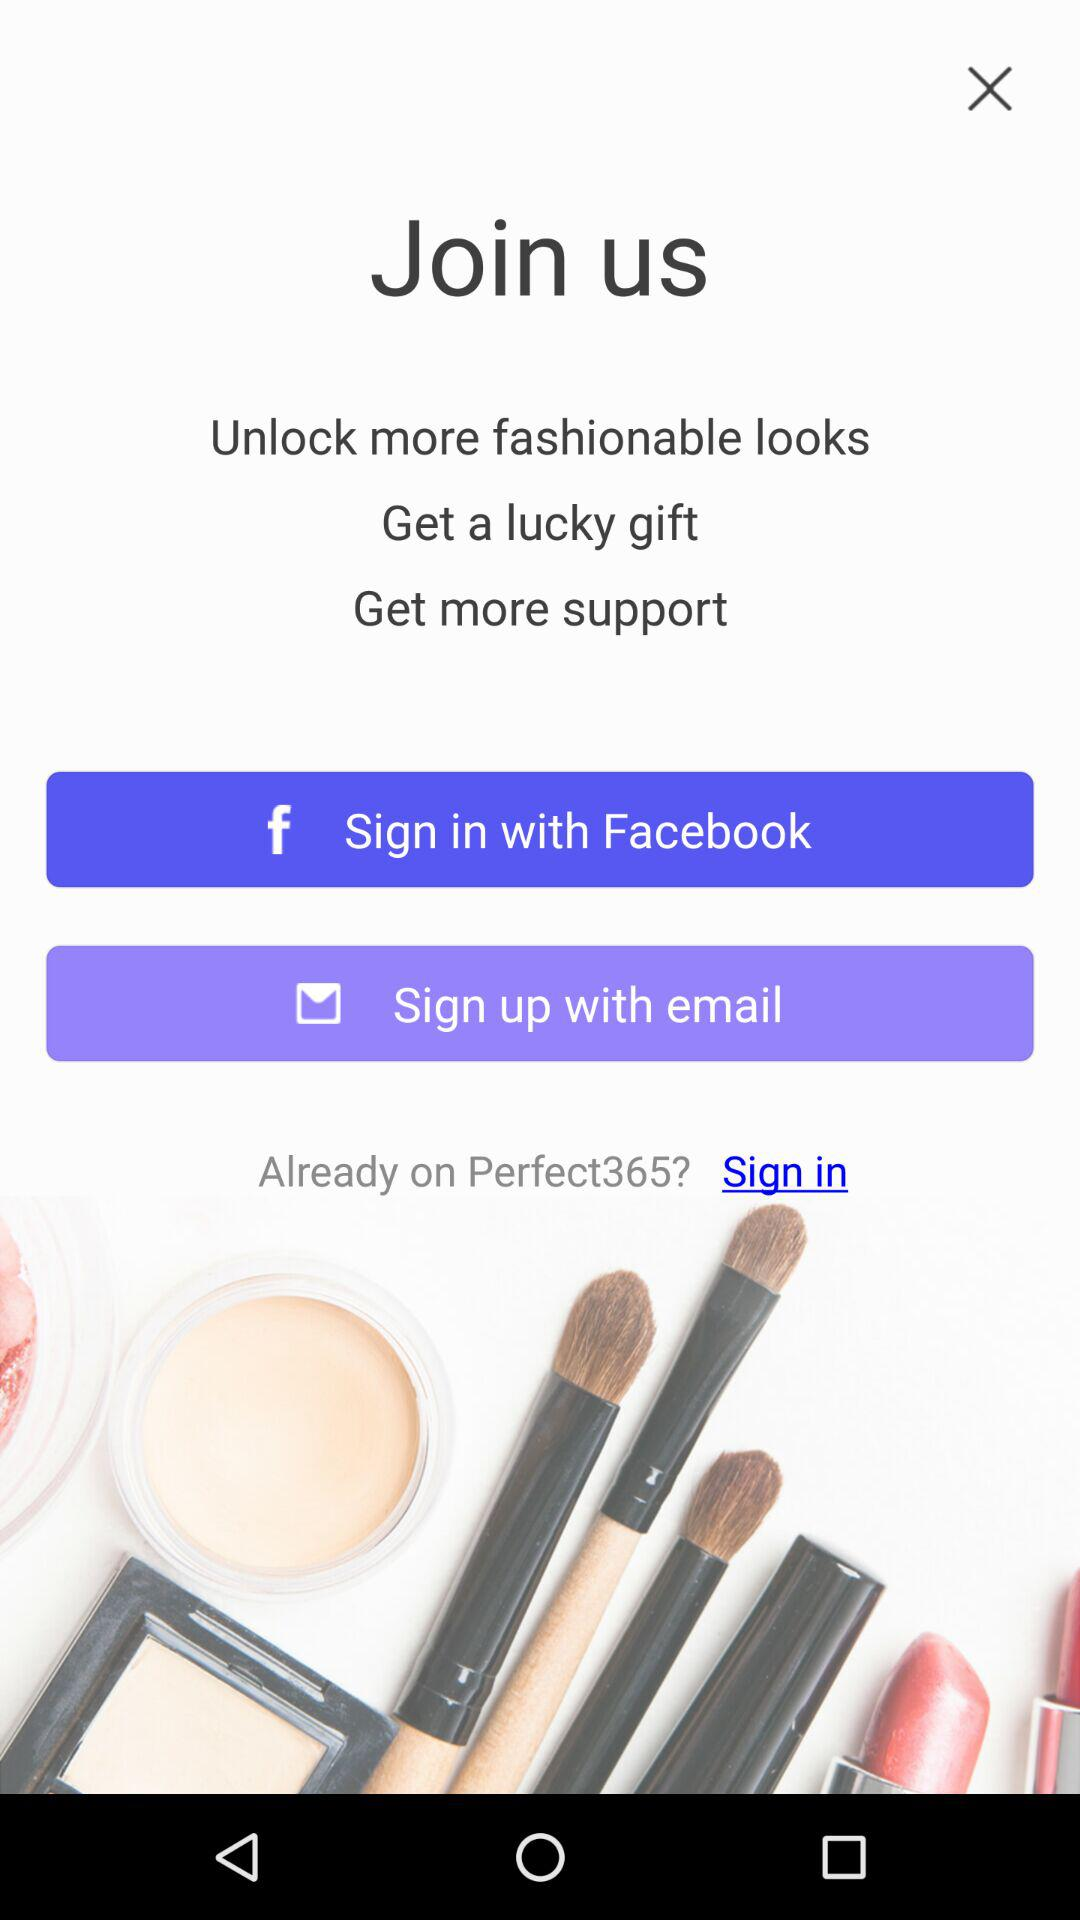What is the name of the application? The name of the application is "Perfect365". 